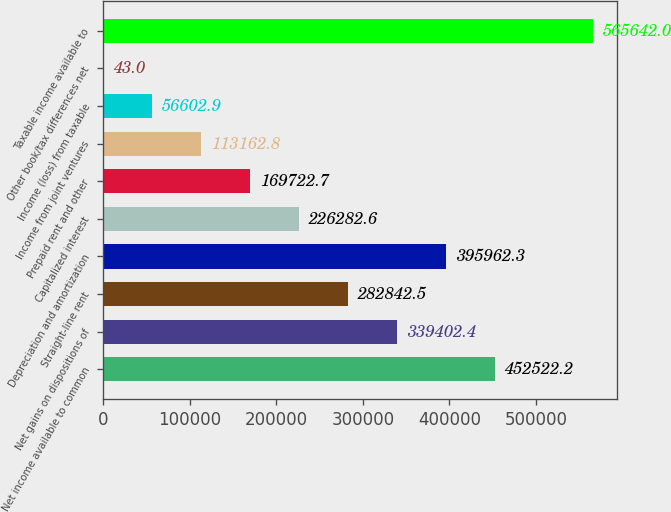Convert chart to OTSL. <chart><loc_0><loc_0><loc_500><loc_500><bar_chart><fcel>Net income available to common<fcel>Net gains on dispositions of<fcel>Straight-line rent<fcel>Depreciation and amortization<fcel>Capitalized interest<fcel>Prepaid rent and other<fcel>Income from joint ventures<fcel>Income (loss) from taxable<fcel>Other book/tax differences net<fcel>Taxable income available to<nl><fcel>452522<fcel>339402<fcel>282842<fcel>395962<fcel>226283<fcel>169723<fcel>113163<fcel>56602.9<fcel>43<fcel>565642<nl></chart> 